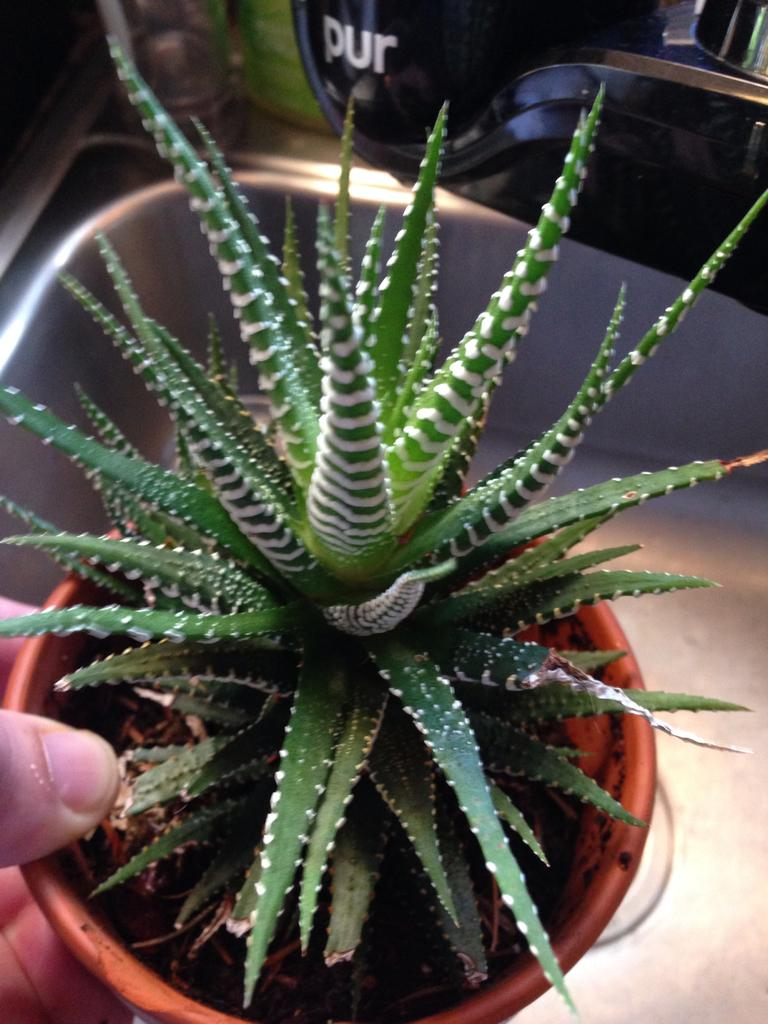What type of plant is visible in the image? There is a houseplant in the image. How is the houseplant being held? The houseplant is being held by human hands. What can be seen in the background of the image? There is a sink in the background of the image. How many territories can be seen in the image? There is no reference to territories in the image; it features a houseplant being held by human hands and a sink in the background. 